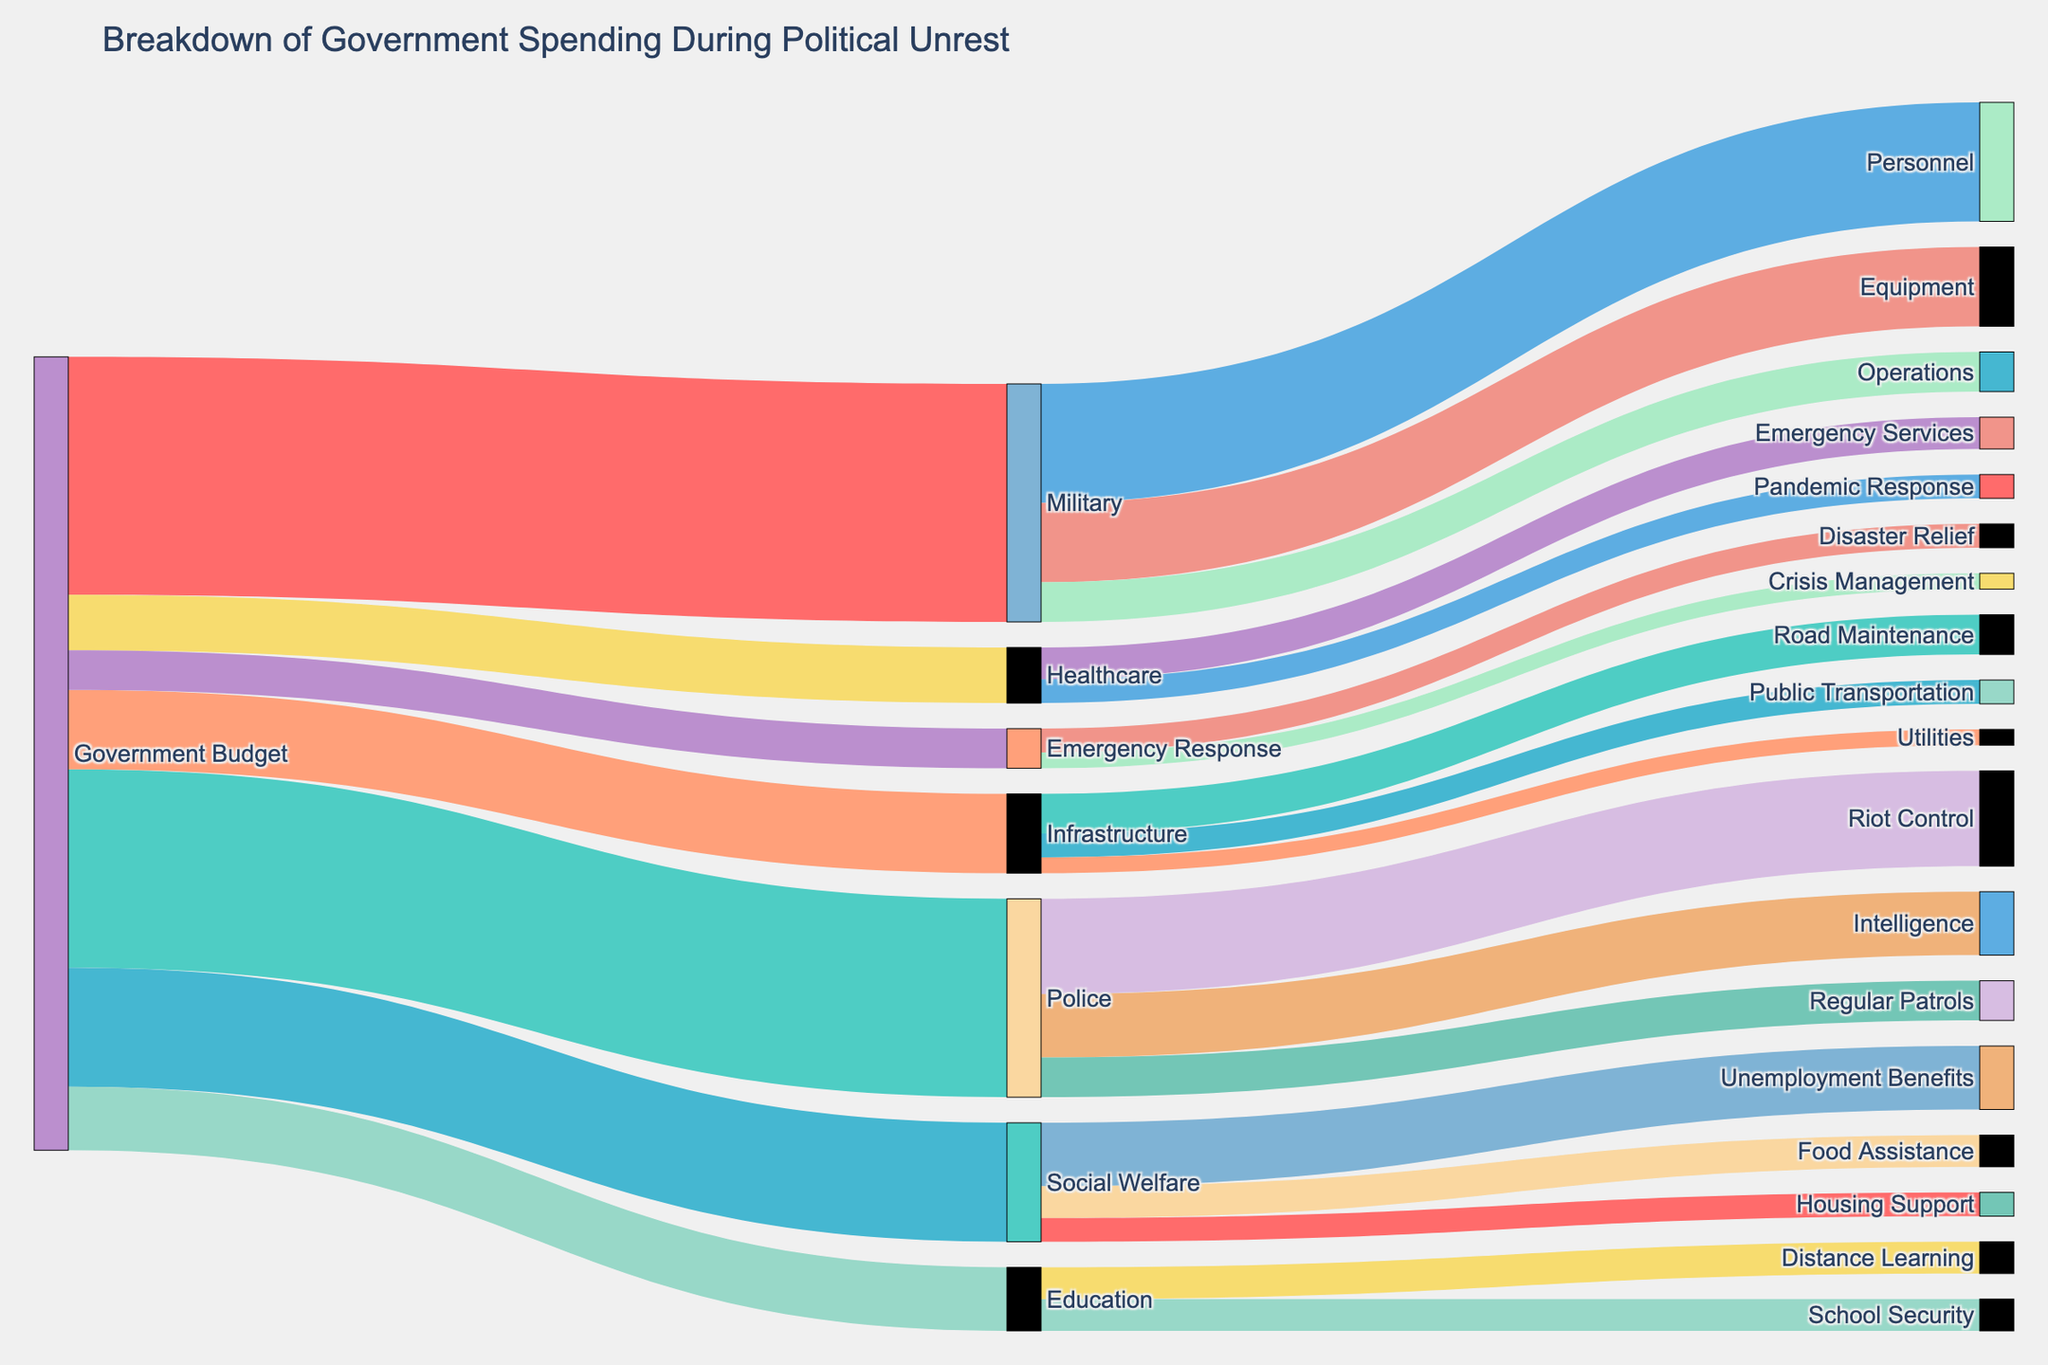What is the title of the figure? The title is displayed at the top of the figure as "Breakdown of Government Spending During Political Unrest."
Answer: Breakdown of Government Spending During Political Unrest What is the total government budget allocation for Military and Police combined? The values for Military and Police from the Government Budget are 30 and 25 respectively. Summing these values: 30 + 25 = 55.
Answer: 55 Which category receives the least amount of funding from the Government Budget? The categories and their values are Military (30), Police (25), Social Welfare (15), Infrastructure (10), Education (8), Healthcare (7), and Emergency Response (5). The smallest value is Emergency Response with 5.
Answer: Emergency Response How does the funding for Infrastructure compare to that for Education? The Government Budget allocation for Infrastructure is 10, while for Education it is 8. Infrastructure receives 2 more units of funding than Education.
Answer: Infrastructure receives 2 more units than Education Which subcategories under Military have the highest and lowest funding? The subcategories under Military are Personnel (15), Equipment (10), and Operations (5). The highest is Personnel with 15, and the lowest is Operations with 5.
Answer: Highest: Personnel, Lowest: Operations What is the total funding allocated to Social Welfare subcategories? The subcategories under Social Welfare are Unemployment Benefits (8), Food Assistance (4), and Housing Support (3). Summing these values: 8 + 4 + 3 = 15.
Answer: 15 How much more funding does Riot Control receive compared to Regular Patrols in the Police category? Riot Control receives 12 and Regular Patrols receive 5. The difference is 12 - 5 = 7.
Answer: 7 What proportion of the Healthcare budget is allocated to Emergency Services? From Healthcare, 4 out of a total of 7 is allocated to Emergency Services. Calculating the proportion: 4/7 ≈ 0.571 or 57.1%.
Answer: 57.1% Describe the flow from Police to its subcategories. The Police category distributes its 25 units of funding to Riot Control (12), Intelligence (8), and Regular Patrols (5).
Answer: Riot Control 12, Intelligence 8, Regular Patrols 5 Which categories do not distribute their budget further into subcategories? The categories without subcategories in the figure are Education and Emergency Response, as no further breakdown is shown for these categories.
Answer: Education and Emergency Response 